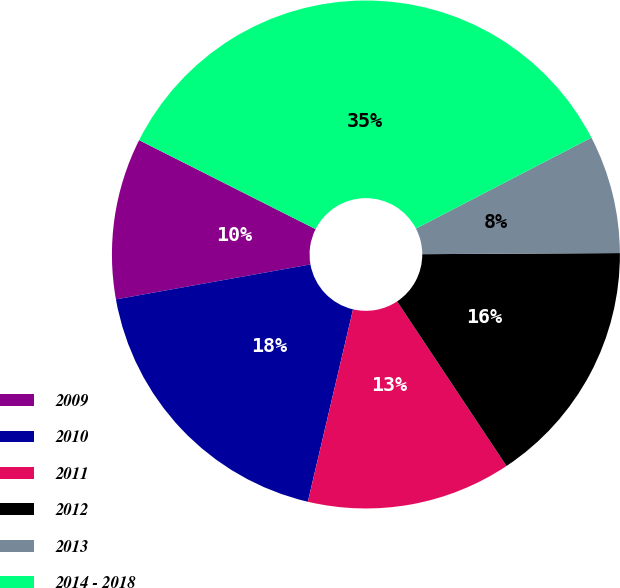<chart> <loc_0><loc_0><loc_500><loc_500><pie_chart><fcel>2009<fcel>2010<fcel>2011<fcel>2012<fcel>2013<fcel>2014 - 2018<nl><fcel>10.26%<fcel>18.5%<fcel>13.01%<fcel>15.75%<fcel>7.52%<fcel>34.96%<nl></chart> 